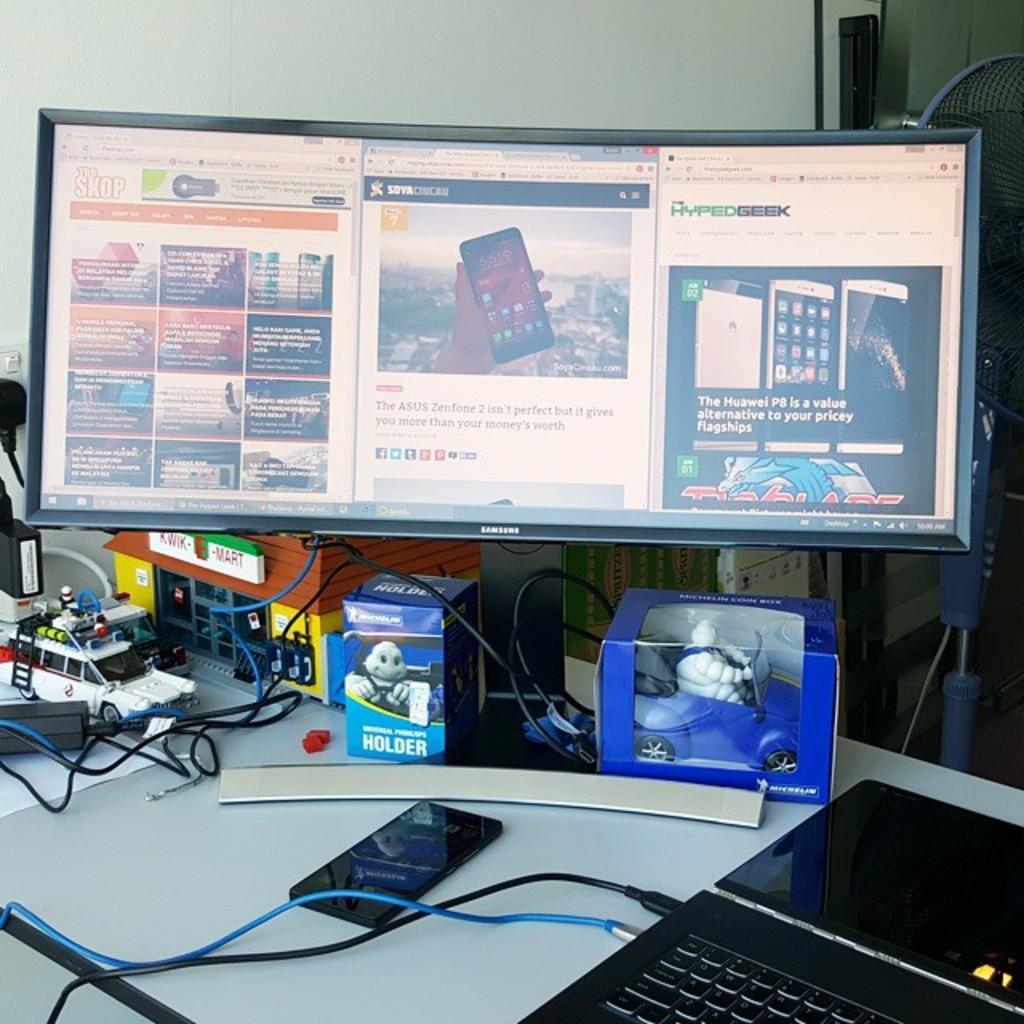What is the brand on the monitor?
Offer a terse response. Samsung. Is that a toy model of a kwik mart?
Make the answer very short. Yes. 